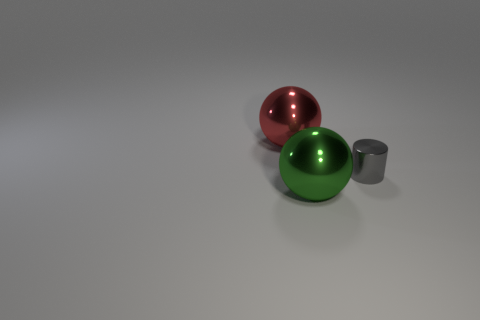Is the material of the sphere on the left side of the large green thing the same as the object to the right of the big green ball?
Offer a very short reply. Yes. What number of things are either large metallic balls behind the small gray cylinder or small gray metallic spheres?
Provide a short and direct response. 1. Are there fewer red metal objects that are to the right of the shiny cylinder than metal cylinders that are in front of the red metal object?
Keep it short and to the point. Yes. What number of other objects are there of the same size as the gray object?
Make the answer very short. 0. How many objects are either metal objects behind the tiny object or things to the left of the green shiny sphere?
Your answer should be very brief. 1. What is the color of the small cylinder?
Offer a terse response. Gray. Are there fewer big red objects that are right of the tiny gray metal cylinder than blue cylinders?
Provide a succinct answer. No. Are there any other things that are the same shape as the red metallic thing?
Keep it short and to the point. Yes. Is there a gray shiny thing?
Ensure brevity in your answer.  Yes. Is the number of small cyan matte things less than the number of red metal spheres?
Offer a very short reply. Yes. 